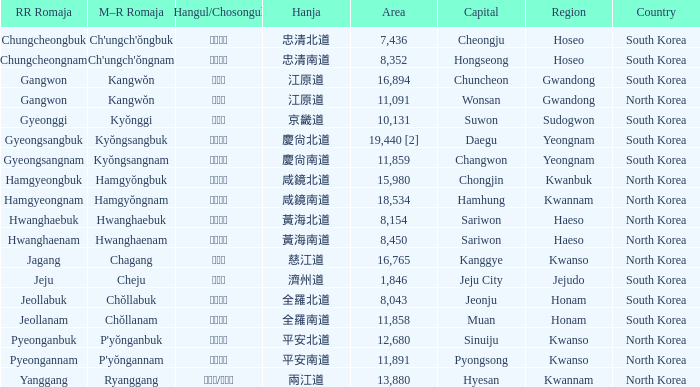Which country has a city with a Hanja of 平安北道? North Korea. 